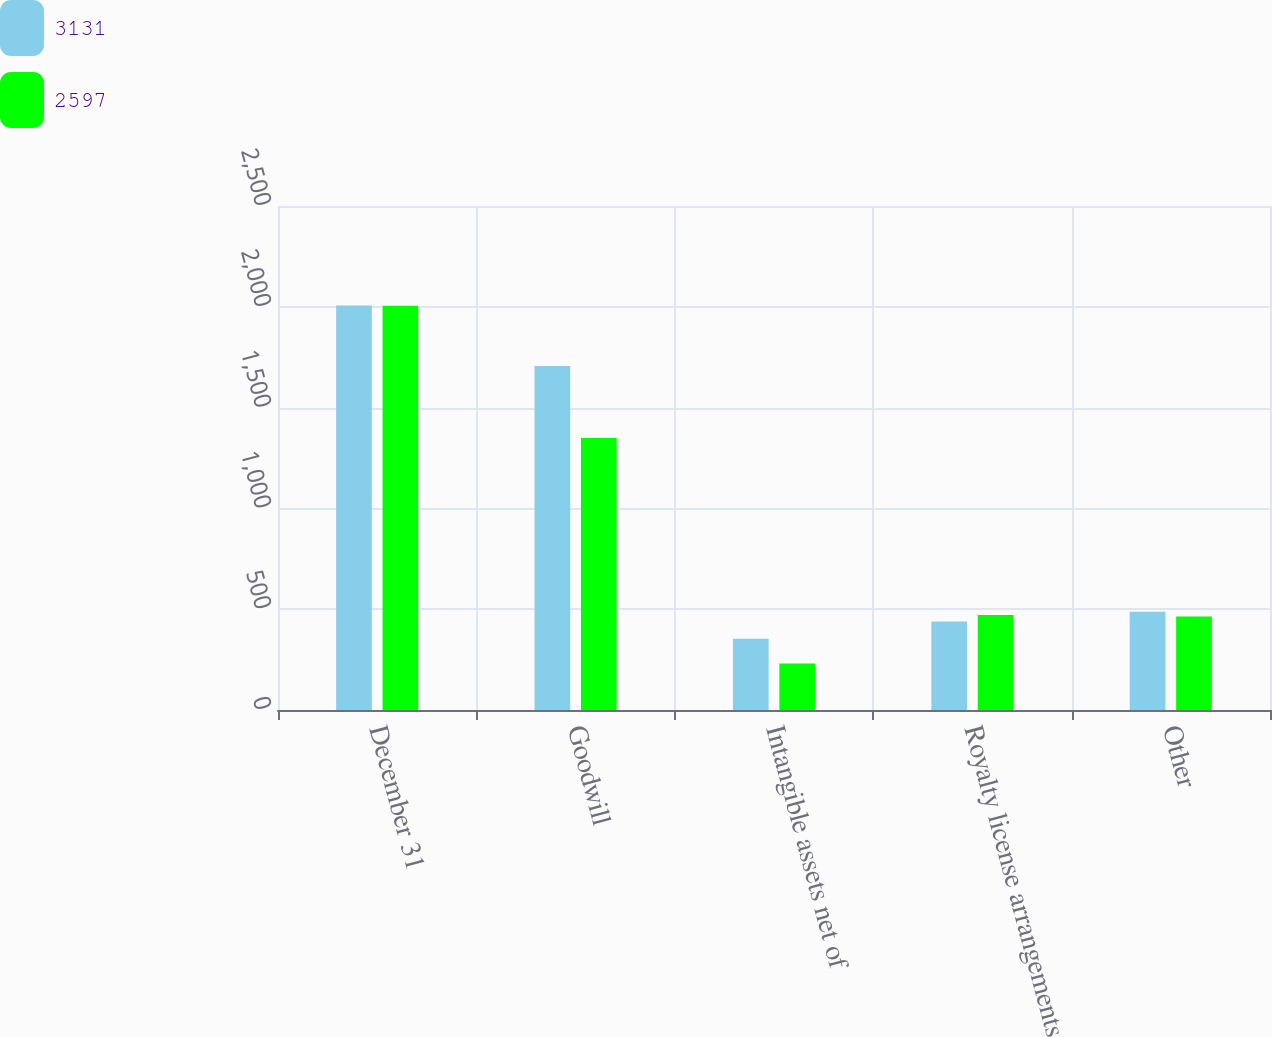Convert chart. <chart><loc_0><loc_0><loc_500><loc_500><stacked_bar_chart><ecel><fcel>December 31<fcel>Goodwill<fcel>Intangible assets net of<fcel>Royalty license arrangements<fcel>Other<nl><fcel>3131<fcel>2006<fcel>1706<fcel>354<fcel>439<fcel>487<nl><fcel>2597<fcel>2005<fcel>1349<fcel>231<fcel>471<fcel>464<nl></chart> 